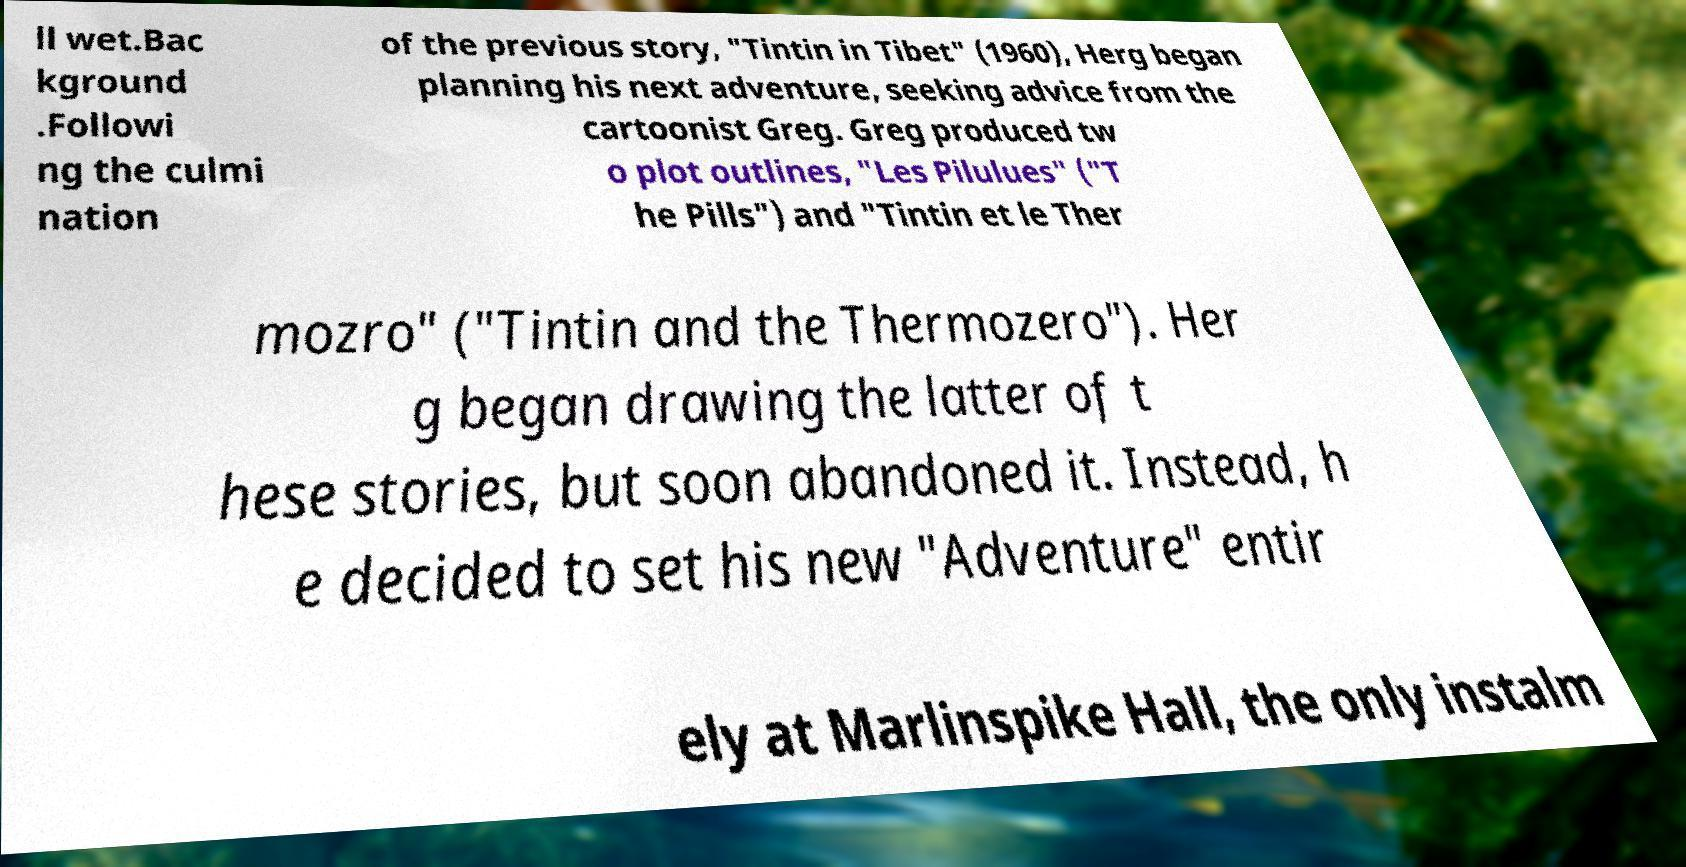What messages or text are displayed in this image? I need them in a readable, typed format. ll wet.Bac kground .Followi ng the culmi nation of the previous story, "Tintin in Tibet" (1960), Herg began planning his next adventure, seeking advice from the cartoonist Greg. Greg produced tw o plot outlines, "Les Pilulues" ("T he Pills") and "Tintin et le Ther mozro" ("Tintin and the Thermozero"). Her g began drawing the latter of t hese stories, but soon abandoned it. Instead, h e decided to set his new "Adventure" entir ely at Marlinspike Hall, the only instalm 